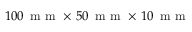Convert formula to latex. <formula><loc_0><loc_0><loc_500><loc_500>1 0 0 \, m m \times \, 5 0 \, m m \times \, 1 0 \, m m</formula> 